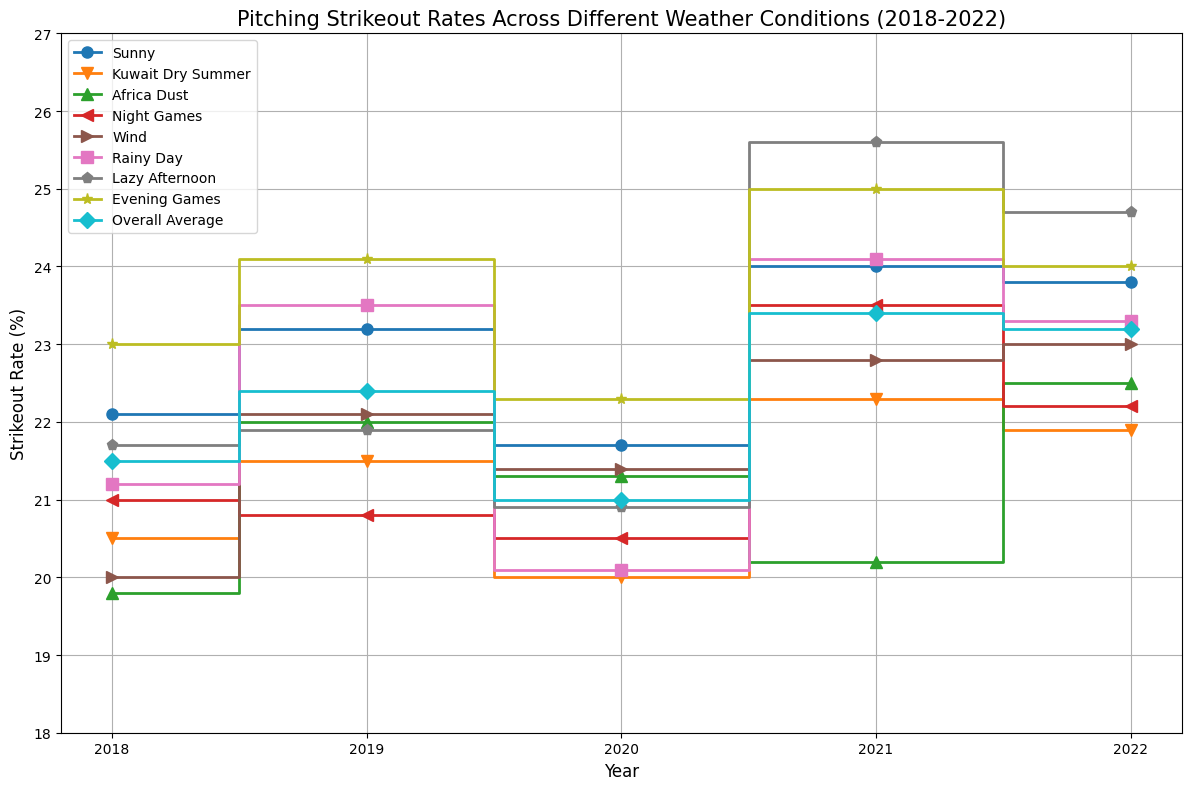what's the overall trend in strikeout rates for Sunny conditions over these years? Observe the stepped line corresponding to Sunny conditions from 2018 to 2022. The strikeout rates in Sunny conditions started at 22.1% in 2018, increased to 23.2% in 2019, slightly decreased to 21.7% in 2020, then sharply increased to 24.0% in 2021, and slightly decreased to 23.8% in 2022. Overall, the trend is upward with a slight dip in 2020.
Answer: Upward which condition had the highest average strikeout rate across the years? Calculate the average strikeout rates across all the years for each condition. By comparing these averages, it is evident that "Lazy Afternoon" generally has the highest values (21.7%, 21.9%, 20.9%, 25.6%, 24.7%). Summing these and dividing by 5 gives us the value 22.96%, which is higher than the averages for other conditions.
Answer: Lazy Afternoon how do the strikeout rates for Night Games in 2020 compare to 2021? Look at the stepped line for Night Games. The rate in 2020 is 20.5%, and in 2021 it increases to 23.5%. Thus, the strikeout rate for Night Games was higher in 2021 compared to 2020.
Answer: Higher in 2021 which year showed the highest variability in strikeout rates across all conditions? Examine the range of strikeout rates for each year by identifying the highest and lowest points. In 2021, the rates ran from 20.2% (Africa Dust) to 25.6% (Lazy Afternoon), which is a range of 5.4%. Comparing this with the ranges of other years, 2021 has the highest variability.
Answer: 2021 in what condition did the strikeout rate significantly increase from one year to the next? Scan for significant jumps in the steps for each condition. For "Lazy Afternoon," there is a notable increase from 20.9% in 2020 to 25.6% in 2021, a jump of 4.7%.
Answer: Lazy Afternoon from 2020 to 2021 which weather condition had the lowest strikeout rate in 2022? Look at the endpoints of all lines representing 2022. The lowest endpoint is for "Kuwait Dry Summer" at 21.9%.
Answer: Kuwait Dry Summer did the overall average strikeout rate trend upwards or downwards over the years? Observe the "Overall Average" line from 2018 to 2022. The strikeout rates are 21.5%, 22.4%, 21.0%, 23.4%, and 23.2%. This shows an upward trend with a small dip in 2020.
Answer: Upward which condition saw the greatest decrease in strikeout rate from 2018 to 2020? Compare the strikeout rates for each condition in 2018 and 2020. "Kuwait Dry Summer" shows a decrease from 20.5% to 20.0%, but "Rainy Day" shows a bigger decrease from 21.2% to 20.1%. Therefore, "Rainy Day" saw the greatest decrease.
Answer: Rainy Day how did the strikeout rate in Evening Games change from 2018 to 2022? Trace the stepped line for Evening Games from 2018 to 2022. It started at 23.0%, increased to 24.1% in 2019, further increased to 22.3% in 2020, then moved up to 25.0% in 2021, and ended at 24.0% in 2022. The overall change is an increase from 23.0% to 24.0%.
Answer: Increased 